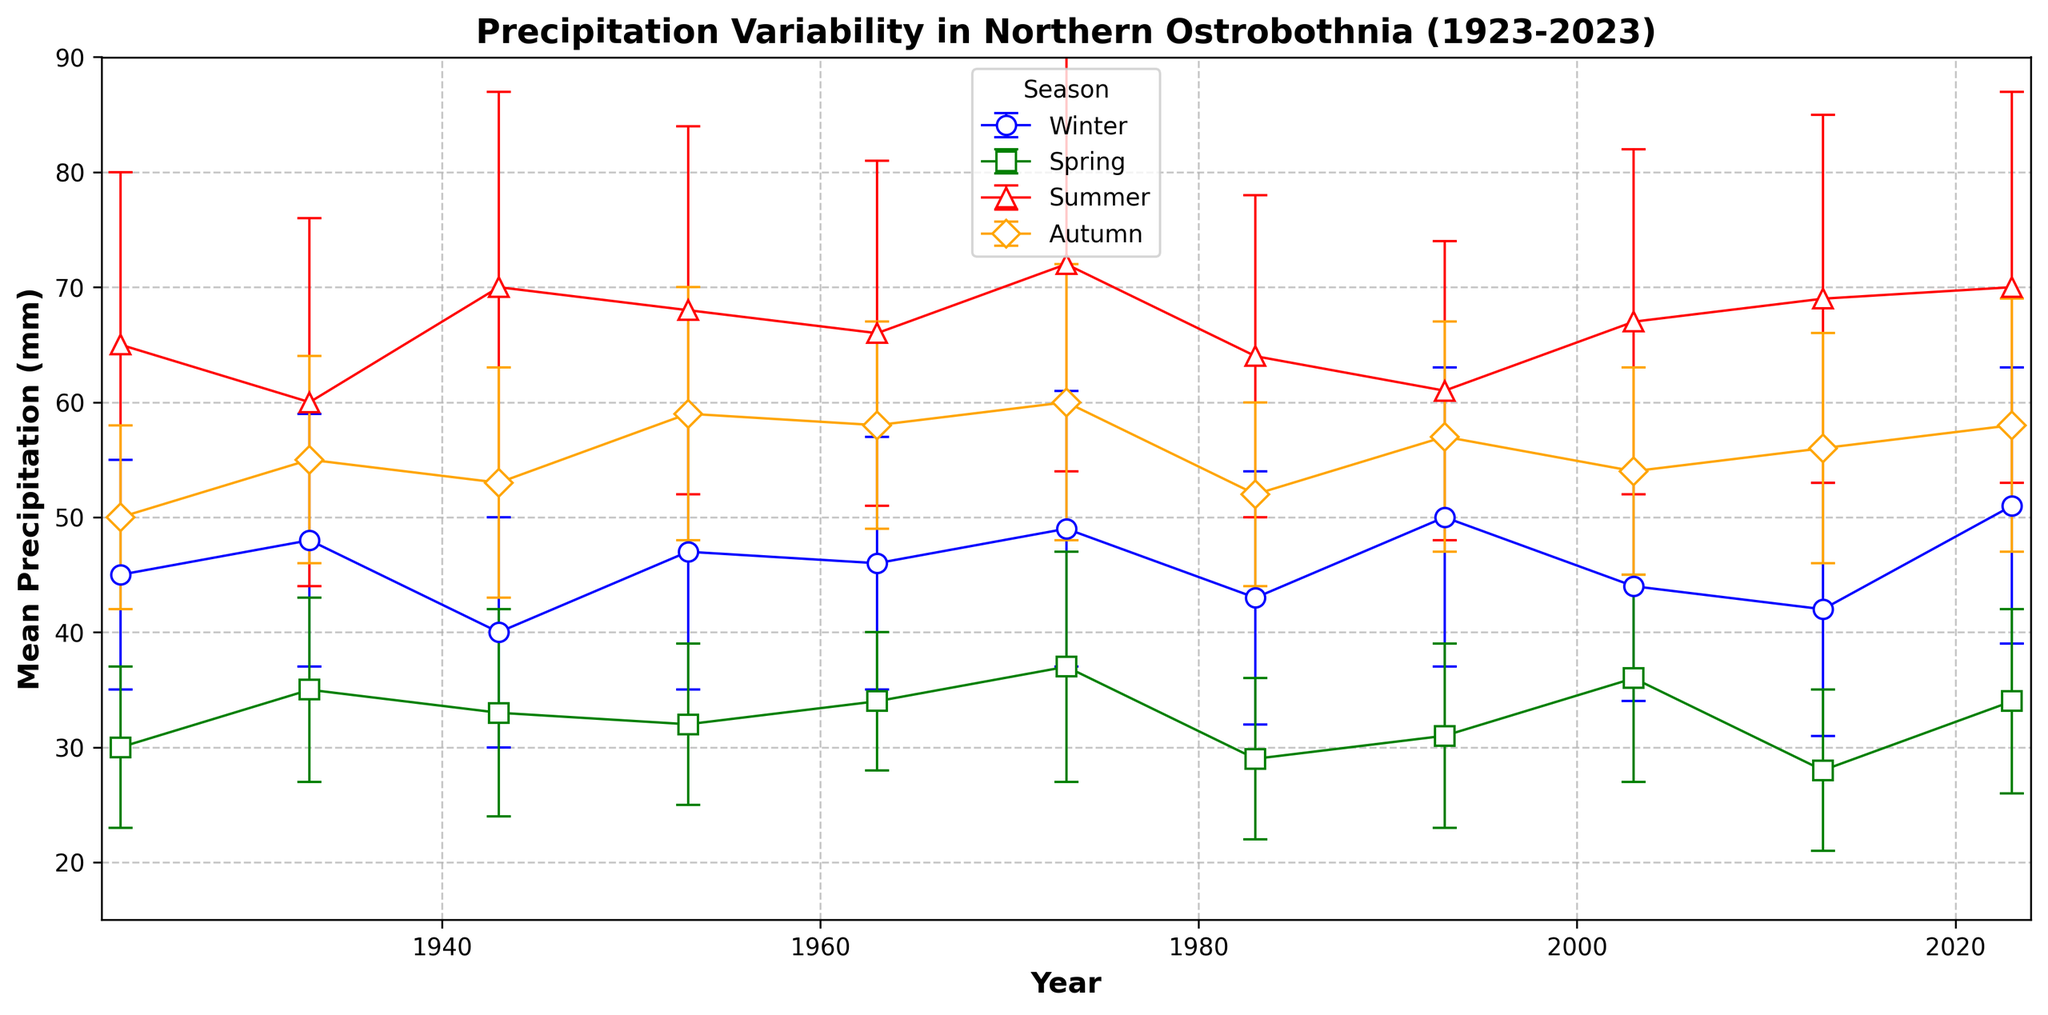What's the mean precipitation in Winter for the year 2023? Locate 'Winter' series in 2023 on the x-axis and check the corresponding value on the y-axis. The mean precipitation for Winter in 2023 is indicated as 51 mm
Answer: 51 Which season had the highest mean precipitation in 1973? Locate 1973 on the x-axis and compare all seasons by the height of their markers. The highest one is for 'Summer' at 72 mm
Answer: Summer What's the difference in mean precipitation between Summer and Spring in 1983? Locate 1983 on the x-axis corresponding to 'Summer' and 'Spring'. 'Summer' has a mean precipitation of 64 mm, and 'Spring' has 29 mm. The difference is 64 - 29 = 35 mm
Answer: 35 In which year did Autumn have the least mean precipitation? Identify 'Autumn' series and compare the heights of markers across years. The lowest value is in 1923 with 50 mm
Answer: 1923 During which season and year did the mean precipitation have the highest variation? The highest variation corresponds to the largest error bar. 'Summer' of 1973 has the largest error bar which indicates the highest standard deviation
Answer: Summer 1973 Compare the mean precipitation of Winter in 1993 and 2003. Which year had more? Locate the 'Winter' markers for 1993 and 2003 on the x-axis. 1993 shows 50 mm, while 2003 shows 44 mm. Thus, 1993 had more
Answer: 1993 What's the average mean precipitation for Summer from 1923 to 2023? Sum the mean precipitation values for 'Summer' from 1923 to 2023 (65 + 60 + 70 + 68 + 66 + 72 + 64 + 61 + 67 + 69 + 70) = 732, then divide by the number of values (732 / 11). The average is approximately 66.5 mm
Answer: 66.5 What is the trend of mean precipitation for Spring from 1923 to 2023? Observe the markers indicating 'Spring' from 1923 to 2023. The mean precipitation starts at 30 mm in 1923 and shows an overall fluctuating pattern without any clear upward or downward trend
Answer: No clear trend Which season’s mean precipitation remained more stable over the years based on the error bars? Compare the size of error bars (representing standard deviation) across all seasons. 'Spring' generally shows smaller error bars indicating more stability
Answer: Spring 